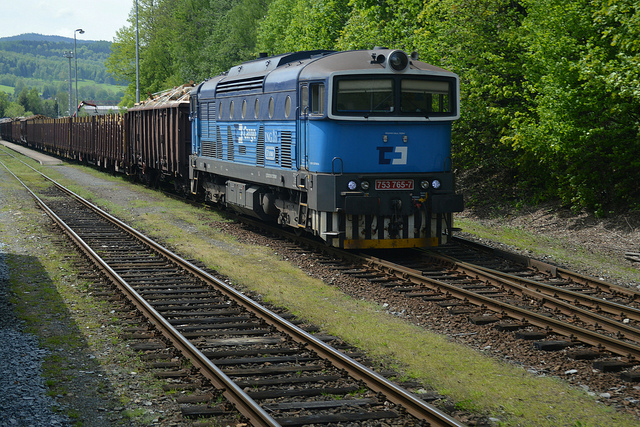Read all the text in this image. 753 